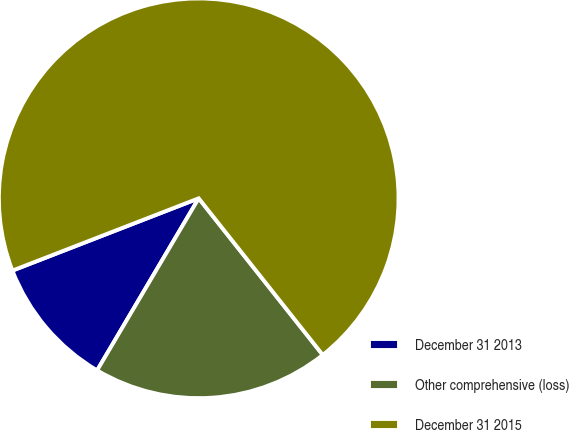Convert chart. <chart><loc_0><loc_0><loc_500><loc_500><pie_chart><fcel>December 31 2013<fcel>Other comprehensive (loss)<fcel>December 31 2015<nl><fcel>10.62%<fcel>19.15%<fcel>70.23%<nl></chart> 